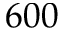Convert formula to latex. <formula><loc_0><loc_0><loc_500><loc_500>6 0 0</formula> 